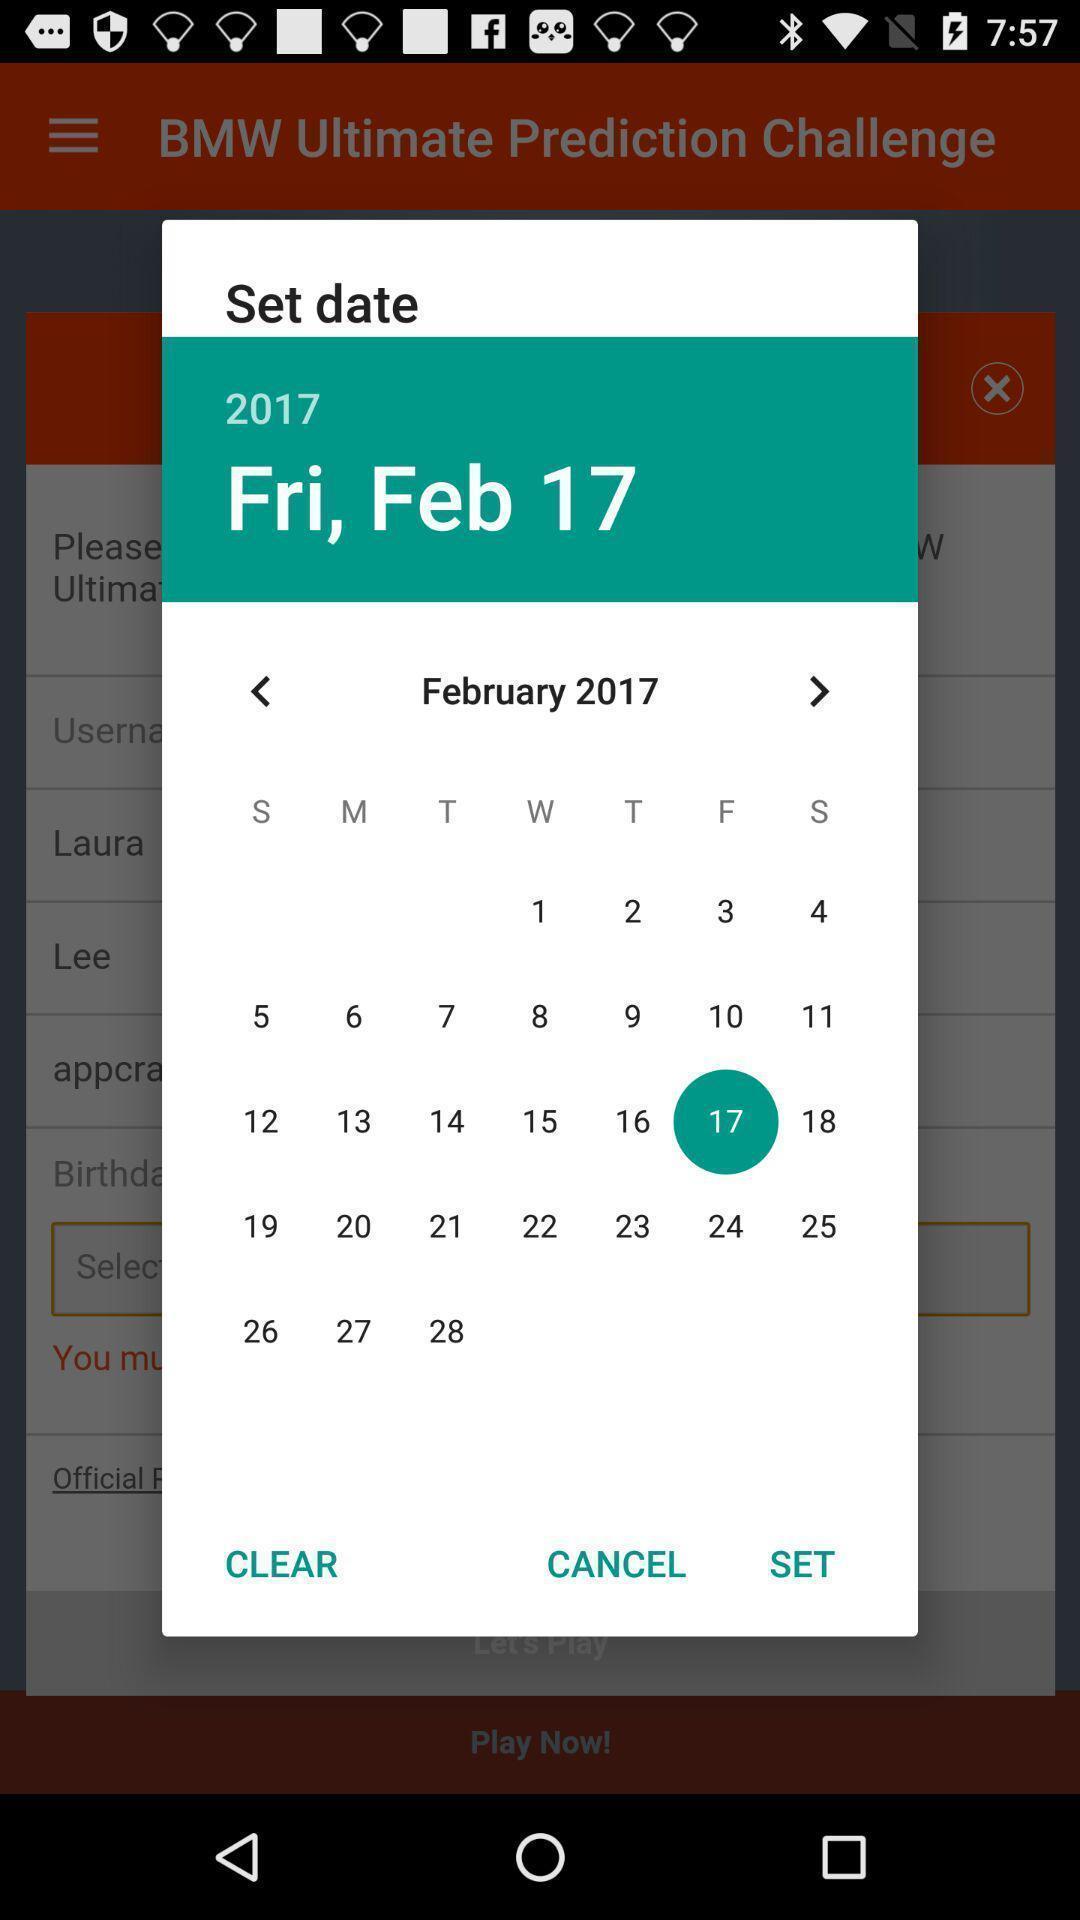What is the overall content of this screenshot? Pop-up showing to set date in a calendar. 